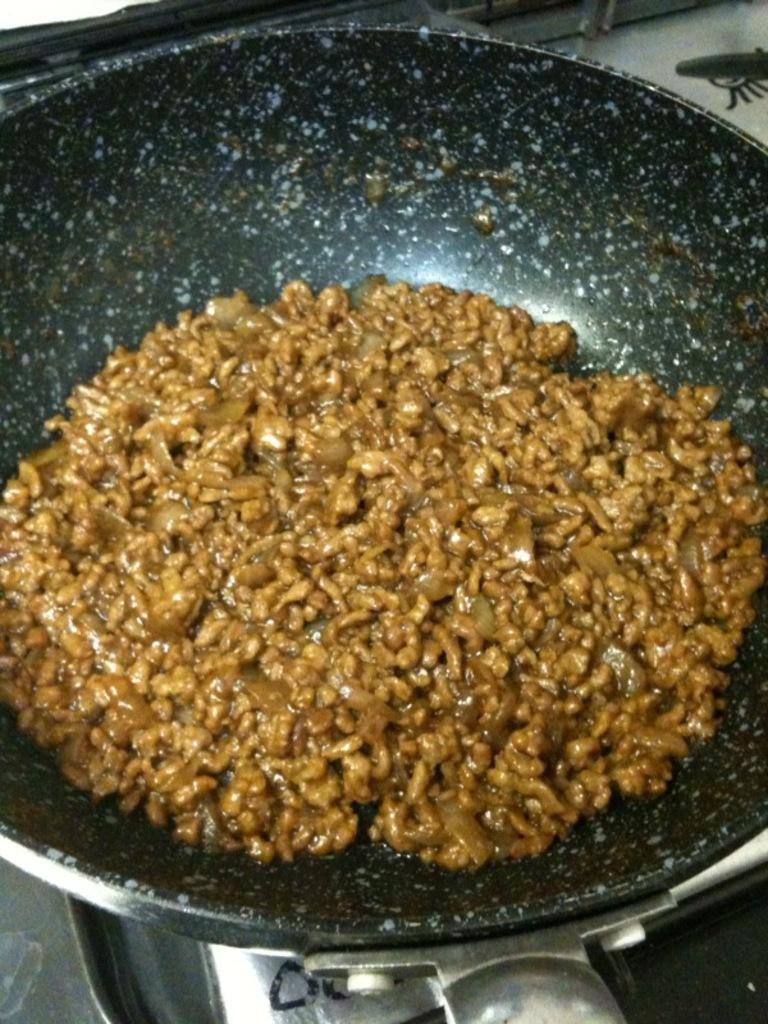What is the main object in the center of the image? There is a pan in the center of the image. What is inside the pan? There is food in the pan. What can be seen at the bottom of the image? There are objects at the bottom of the image. How does the pan rub against the objects at the bottom of the image? The pan does not rub against the objects at the bottom of the image; it is stationary in the center of the image. 